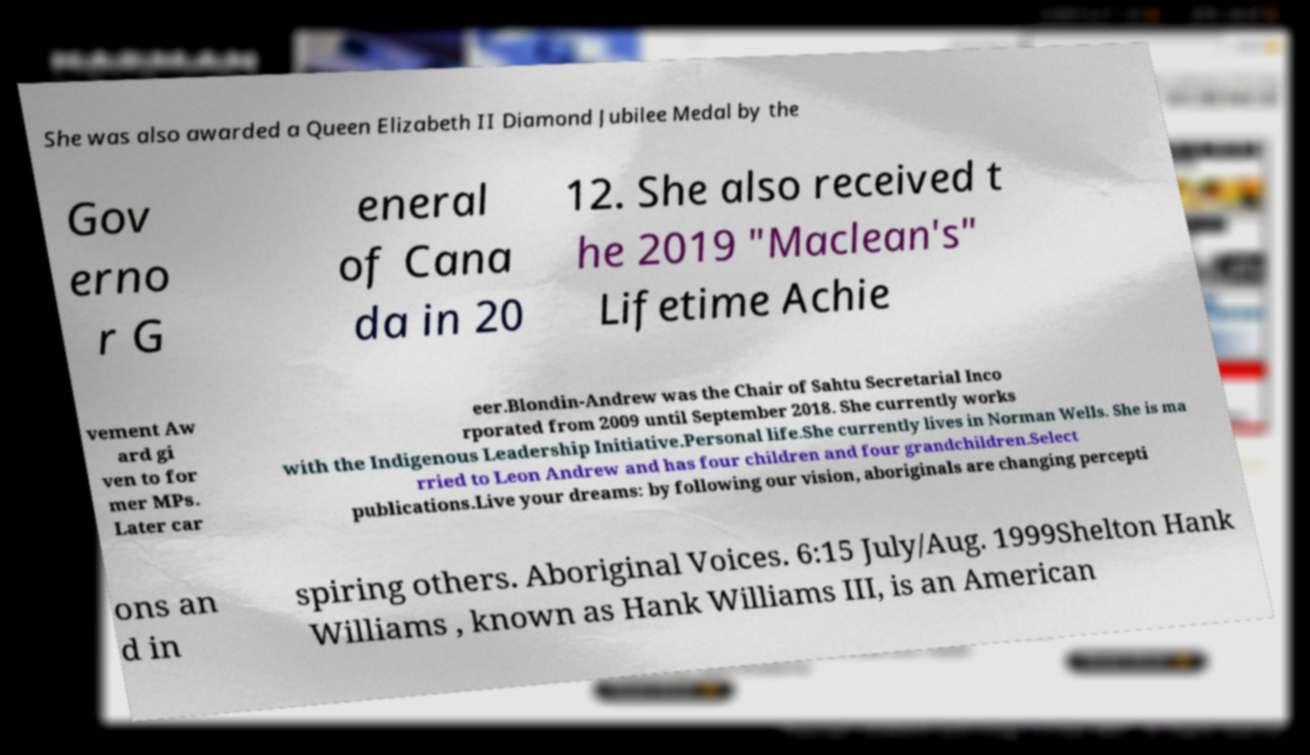What messages or text are displayed in this image? I need them in a readable, typed format. She was also awarded a Queen Elizabeth II Diamond Jubilee Medal by the Gov erno r G eneral of Cana da in 20 12. She also received t he 2019 "Maclean's" Lifetime Achie vement Aw ard gi ven to for mer MPs. Later car eer.Blondin-Andrew was the Chair of Sahtu Secretarial Inco rporated from 2009 until September 2018. She currently works with the Indigenous Leadership Initiative.Personal life.She currently lives in Norman Wells. She is ma rried to Leon Andrew and has four children and four grandchildren.Select publications.Live your dreams: by following our vision, aboriginals are changing percepti ons an d in spiring others. Aboriginal Voices. 6:15 July/Aug. 1999Shelton Hank Williams , known as Hank Williams III, is an American 